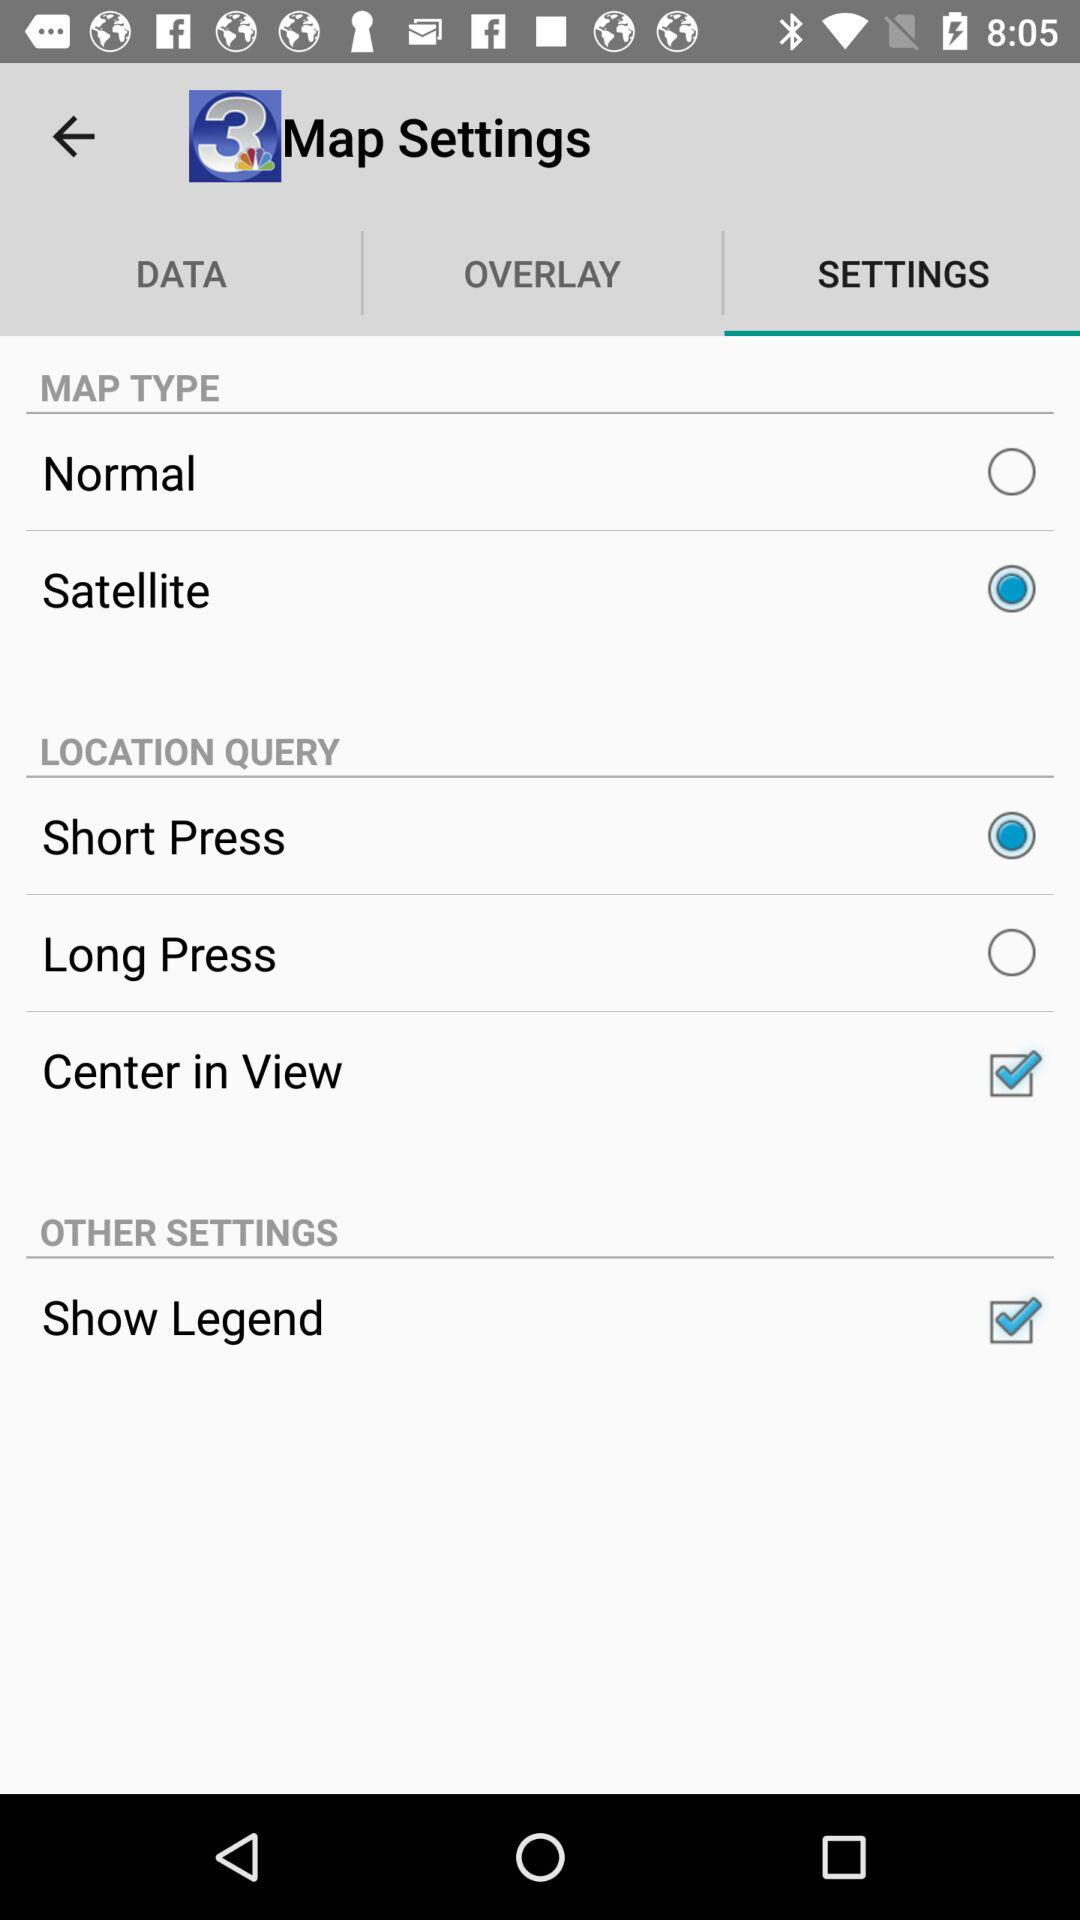Which map type is used? The used map type is "Satellite". 